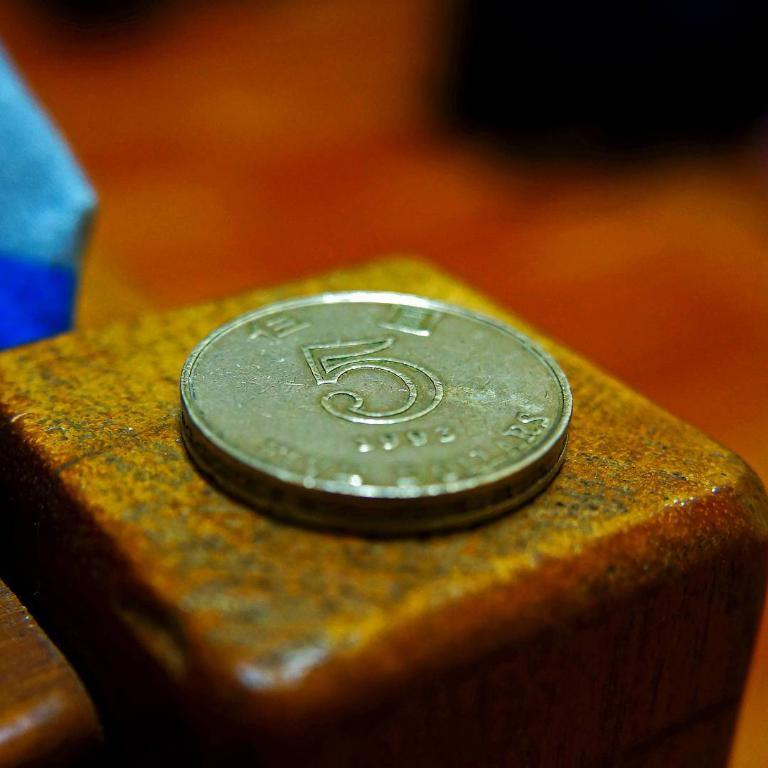How much is the coin worth?
Provide a short and direct response. 5. What year is on the coin?
Give a very brief answer. 1993. 